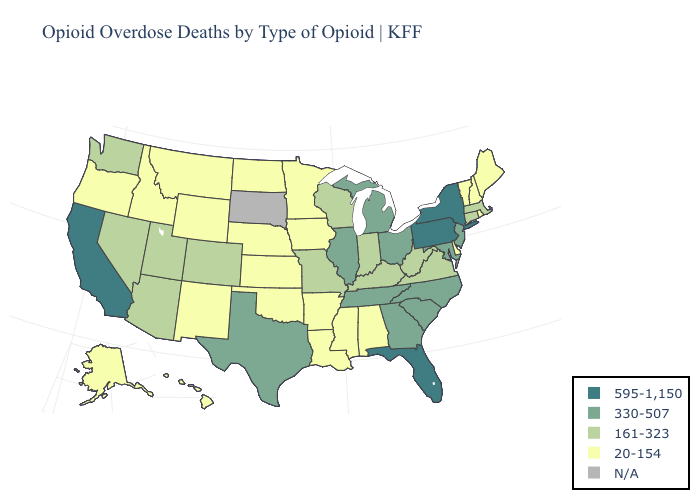What is the lowest value in the USA?
Keep it brief. 20-154. What is the value of Rhode Island?
Write a very short answer. 20-154. Name the states that have a value in the range 595-1,150?
Concise answer only. California, Florida, New York, Pennsylvania. What is the highest value in the South ?
Quick response, please. 595-1,150. Which states hav the highest value in the West?
Quick response, please. California. What is the lowest value in the USA?
Be succinct. 20-154. Which states have the lowest value in the Northeast?
Short answer required. Maine, New Hampshire, Rhode Island, Vermont. Does Connecticut have the lowest value in the USA?
Write a very short answer. No. What is the value of Kentucky?
Be succinct. 161-323. How many symbols are there in the legend?
Give a very brief answer. 5. Name the states that have a value in the range 161-323?
Be succinct. Arizona, Colorado, Connecticut, Indiana, Kentucky, Massachusetts, Missouri, Nevada, Utah, Virginia, Washington, West Virginia, Wisconsin. What is the value of North Carolina?
Quick response, please. 330-507. Among the states that border Delaware , which have the lowest value?
Keep it brief. Maryland, New Jersey. 